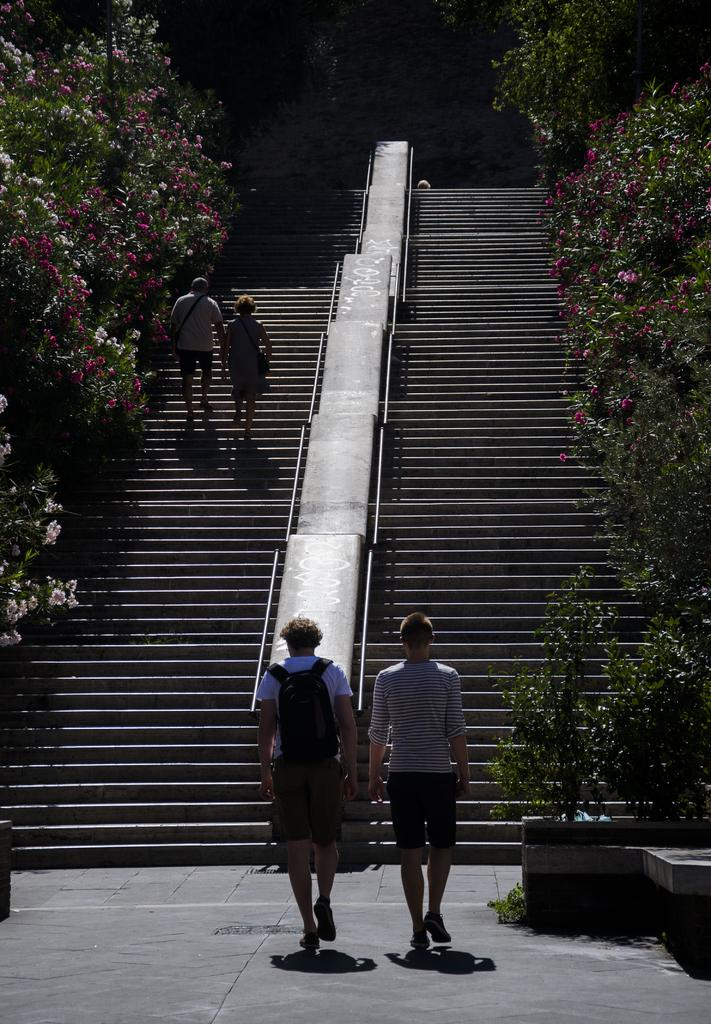How many people are in the image? There are four members in the image. Where are two of the members located? Two of the members are on the stairs. What is in the middle of the image? There are stairs in the middle of the image. What can be seen on either side of the image? There are trees on either side of the image. What type of cheese is being used for the science experiment in the image? There is no cheese or science experiment present in the image. 